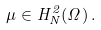<formula> <loc_0><loc_0><loc_500><loc_500>\mu \in H _ { N } ^ { 2 } ( \Omega ) \, .</formula> 